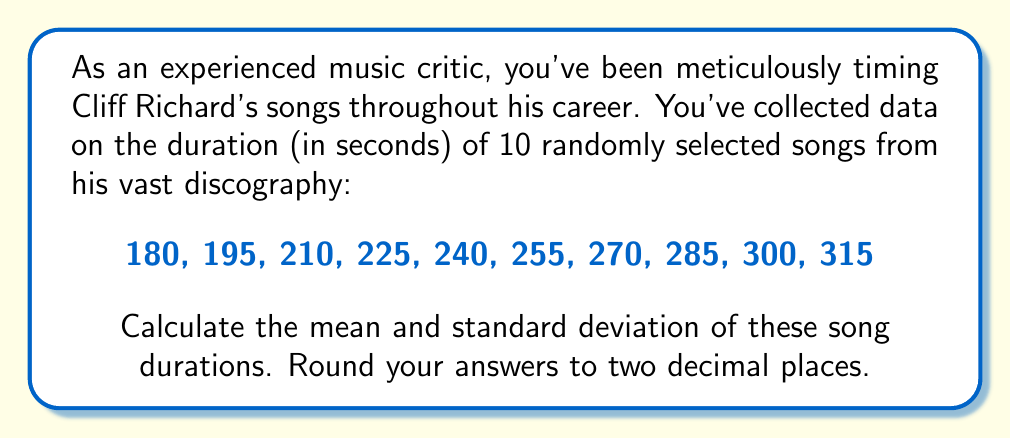What is the answer to this math problem? To solve this problem, we'll follow these steps:

1. Calculate the mean (average) of the song durations.
2. Calculate the variance.
3. Calculate the standard deviation.

Step 1: Calculate the mean

The formula for the mean is:

$$ \bar{x} = \frac{\sum_{i=1}^{n} x_i}{n} $$

where $x_i$ are the individual values and $n$ is the number of values.

$$ \bar{x} = \frac{180 + 195 + 210 + 225 + 240 + 255 + 270 + 285 + 300 + 315}{10} = \frac{2475}{10} = 247.5 $$

Step 2: Calculate the variance

The formula for variance is:

$$ s^2 = \frac{\sum_{i=1}^{n} (x_i - \bar{x})^2}{n - 1} $$

First, we calculate $(x_i - \bar{x})^2$ for each value:

$(180 - 247.5)^2 = (-67.5)^2 = 4556.25$
$(195 - 247.5)^2 = (-52.5)^2 = 2756.25$
$(210 - 247.5)^2 = (-37.5)^2 = 1406.25$
$(225 - 247.5)^2 = (-22.5)^2 = 506.25$
$(240 - 247.5)^2 = (-7.5)^2 = 56.25$
$(255 - 247.5)^2 = (7.5)^2 = 56.25$
$(270 - 247.5)^2 = (22.5)^2 = 506.25$
$(285 - 247.5)^2 = (37.5)^2 = 1406.25$
$(300 - 247.5)^2 = (52.5)^2 = 2756.25$
$(315 - 247.5)^2 = (67.5)^2 = 4556.25$

Sum these values:

$$ \sum_{i=1}^{n} (x_i - \bar{x})^2 = 18562.5 $$

Now, we can calculate the variance:

$$ s^2 = \frac{18562.5}{10 - 1} = 2062.5 $$

Step 3: Calculate the standard deviation

The standard deviation is the square root of the variance:

$$ s = \sqrt{s^2} = \sqrt{2062.5} \approx 45.41 $$

Rounding to two decimal places, we get 45.41.
Answer: Mean: 247.50 seconds
Standard Deviation: 45.41 seconds 